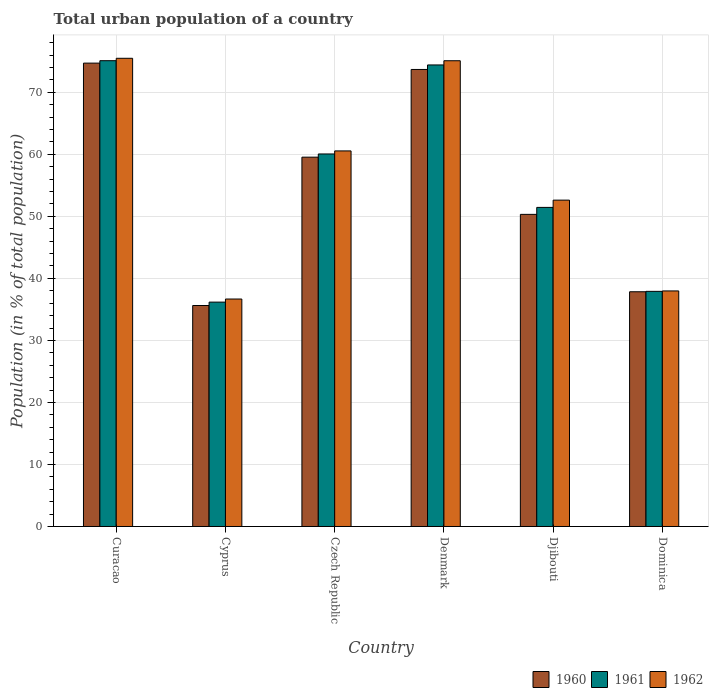Are the number of bars per tick equal to the number of legend labels?
Your answer should be compact. Yes. What is the label of the 3rd group of bars from the left?
Your answer should be very brief. Czech Republic. What is the urban population in 1960 in Dominica?
Your answer should be very brief. 37.85. Across all countries, what is the maximum urban population in 1961?
Ensure brevity in your answer.  75.1. Across all countries, what is the minimum urban population in 1960?
Ensure brevity in your answer.  35.63. In which country was the urban population in 1960 maximum?
Your answer should be compact. Curacao. In which country was the urban population in 1961 minimum?
Give a very brief answer. Cyprus. What is the total urban population in 1961 in the graph?
Provide a short and direct response. 335.12. What is the difference between the urban population in 1962 in Curacao and that in Djibouti?
Ensure brevity in your answer.  22.87. What is the difference between the urban population in 1960 in Dominica and the urban population in 1962 in Djibouti?
Provide a succinct answer. -14.77. What is the average urban population in 1961 per country?
Provide a short and direct response. 55.85. What is the difference between the urban population of/in 1962 and urban population of/in 1960 in Denmark?
Offer a very short reply. 1.41. In how many countries, is the urban population in 1961 greater than 18 %?
Ensure brevity in your answer.  6. What is the ratio of the urban population in 1962 in Czech Republic to that in Dominica?
Offer a very short reply. 1.59. Is the difference between the urban population in 1962 in Cyprus and Djibouti greater than the difference between the urban population in 1960 in Cyprus and Djibouti?
Provide a succinct answer. No. What is the difference between the highest and the second highest urban population in 1962?
Make the answer very short. -0.4. What is the difference between the highest and the lowest urban population in 1961?
Give a very brief answer. 38.93. Is the sum of the urban population in 1962 in Curacao and Dominica greater than the maximum urban population in 1960 across all countries?
Give a very brief answer. Yes. What does the 2nd bar from the left in Curacao represents?
Keep it short and to the point. 1961. What does the 3rd bar from the right in Dominica represents?
Offer a very short reply. 1960. Is it the case that in every country, the sum of the urban population in 1961 and urban population in 1960 is greater than the urban population in 1962?
Provide a short and direct response. Yes. What is the difference between two consecutive major ticks on the Y-axis?
Ensure brevity in your answer.  10. Are the values on the major ticks of Y-axis written in scientific E-notation?
Ensure brevity in your answer.  No. Does the graph contain any zero values?
Offer a terse response. No. Where does the legend appear in the graph?
Your answer should be compact. Bottom right. How many legend labels are there?
Provide a succinct answer. 3. What is the title of the graph?
Your response must be concise. Total urban population of a country. What is the label or title of the X-axis?
Your answer should be compact. Country. What is the label or title of the Y-axis?
Provide a succinct answer. Population (in % of total population). What is the Population (in % of total population) in 1960 in Curacao?
Your answer should be compact. 74.71. What is the Population (in % of total population) in 1961 in Curacao?
Give a very brief answer. 75.1. What is the Population (in % of total population) in 1962 in Curacao?
Provide a succinct answer. 75.49. What is the Population (in % of total population) in 1960 in Cyprus?
Provide a short and direct response. 35.63. What is the Population (in % of total population) of 1961 in Cyprus?
Offer a very short reply. 36.17. What is the Population (in % of total population) in 1962 in Cyprus?
Offer a terse response. 36.67. What is the Population (in % of total population) of 1960 in Czech Republic?
Provide a short and direct response. 59.55. What is the Population (in % of total population) in 1961 in Czech Republic?
Your answer should be very brief. 60.06. What is the Population (in % of total population) in 1962 in Czech Republic?
Give a very brief answer. 60.55. What is the Population (in % of total population) in 1960 in Denmark?
Provide a short and direct response. 73.69. What is the Population (in % of total population) in 1961 in Denmark?
Provide a succinct answer. 74.42. What is the Population (in % of total population) in 1962 in Denmark?
Your answer should be very brief. 75.09. What is the Population (in % of total population) in 1960 in Djibouti?
Give a very brief answer. 50.33. What is the Population (in % of total population) of 1961 in Djibouti?
Provide a short and direct response. 51.45. What is the Population (in % of total population) in 1962 in Djibouti?
Provide a short and direct response. 52.62. What is the Population (in % of total population) in 1960 in Dominica?
Ensure brevity in your answer.  37.85. What is the Population (in % of total population) in 1961 in Dominica?
Your answer should be compact. 37.91. What is the Population (in % of total population) of 1962 in Dominica?
Your answer should be compact. 37.98. Across all countries, what is the maximum Population (in % of total population) in 1960?
Offer a very short reply. 74.71. Across all countries, what is the maximum Population (in % of total population) in 1961?
Your answer should be compact. 75.1. Across all countries, what is the maximum Population (in % of total population) of 1962?
Ensure brevity in your answer.  75.49. Across all countries, what is the minimum Population (in % of total population) in 1960?
Keep it short and to the point. 35.63. Across all countries, what is the minimum Population (in % of total population) of 1961?
Give a very brief answer. 36.17. Across all countries, what is the minimum Population (in % of total population) of 1962?
Offer a very short reply. 36.67. What is the total Population (in % of total population) of 1960 in the graph?
Offer a very short reply. 331.74. What is the total Population (in % of total population) of 1961 in the graph?
Ensure brevity in your answer.  335.12. What is the total Population (in % of total population) in 1962 in the graph?
Ensure brevity in your answer.  338.41. What is the difference between the Population (in % of total population) in 1960 in Curacao and that in Cyprus?
Your response must be concise. 39.08. What is the difference between the Population (in % of total population) of 1961 in Curacao and that in Cyprus?
Provide a succinct answer. 38.93. What is the difference between the Population (in % of total population) of 1962 in Curacao and that in Cyprus?
Your answer should be compact. 38.82. What is the difference between the Population (in % of total population) in 1960 in Curacao and that in Czech Republic?
Make the answer very short. 15.16. What is the difference between the Population (in % of total population) of 1961 in Curacao and that in Czech Republic?
Ensure brevity in your answer.  15.04. What is the difference between the Population (in % of total population) of 1962 in Curacao and that in Czech Republic?
Provide a succinct answer. 14.94. What is the difference between the Population (in % of total population) in 1961 in Curacao and that in Denmark?
Keep it short and to the point. 0.69. What is the difference between the Population (in % of total population) of 1962 in Curacao and that in Denmark?
Your response must be concise. 0.4. What is the difference between the Population (in % of total population) of 1960 in Curacao and that in Djibouti?
Your answer should be compact. 24.39. What is the difference between the Population (in % of total population) in 1961 in Curacao and that in Djibouti?
Provide a short and direct response. 23.65. What is the difference between the Population (in % of total population) of 1962 in Curacao and that in Djibouti?
Offer a very short reply. 22.87. What is the difference between the Population (in % of total population) in 1960 in Curacao and that in Dominica?
Provide a short and direct response. 36.86. What is the difference between the Population (in % of total population) of 1961 in Curacao and that in Dominica?
Give a very brief answer. 37.19. What is the difference between the Population (in % of total population) in 1962 in Curacao and that in Dominica?
Keep it short and to the point. 37.51. What is the difference between the Population (in % of total population) in 1960 in Cyprus and that in Czech Republic?
Your answer should be compact. -23.92. What is the difference between the Population (in % of total population) in 1961 in Cyprus and that in Czech Republic?
Give a very brief answer. -23.89. What is the difference between the Population (in % of total population) in 1962 in Cyprus and that in Czech Republic?
Your answer should be very brief. -23.88. What is the difference between the Population (in % of total population) of 1960 in Cyprus and that in Denmark?
Your response must be concise. -38.06. What is the difference between the Population (in % of total population) of 1961 in Cyprus and that in Denmark?
Your answer should be compact. -38.24. What is the difference between the Population (in % of total population) in 1962 in Cyprus and that in Denmark?
Make the answer very short. -38.42. What is the difference between the Population (in % of total population) in 1960 in Cyprus and that in Djibouti?
Offer a terse response. -14.7. What is the difference between the Population (in % of total population) in 1961 in Cyprus and that in Djibouti?
Keep it short and to the point. -15.27. What is the difference between the Population (in % of total population) in 1962 in Cyprus and that in Djibouti?
Provide a succinct answer. -15.95. What is the difference between the Population (in % of total population) of 1960 in Cyprus and that in Dominica?
Ensure brevity in your answer.  -2.22. What is the difference between the Population (in % of total population) of 1961 in Cyprus and that in Dominica?
Your response must be concise. -1.74. What is the difference between the Population (in % of total population) of 1962 in Cyprus and that in Dominica?
Your response must be concise. -1.3. What is the difference between the Population (in % of total population) in 1960 in Czech Republic and that in Denmark?
Keep it short and to the point. -14.14. What is the difference between the Population (in % of total population) in 1961 in Czech Republic and that in Denmark?
Keep it short and to the point. -14.35. What is the difference between the Population (in % of total population) of 1962 in Czech Republic and that in Denmark?
Make the answer very short. -14.54. What is the difference between the Population (in % of total population) of 1960 in Czech Republic and that in Djibouti?
Ensure brevity in your answer.  9.22. What is the difference between the Population (in % of total population) of 1961 in Czech Republic and that in Djibouti?
Your response must be concise. 8.62. What is the difference between the Population (in % of total population) of 1962 in Czech Republic and that in Djibouti?
Your response must be concise. 7.94. What is the difference between the Population (in % of total population) of 1960 in Czech Republic and that in Dominica?
Your answer should be very brief. 21.7. What is the difference between the Population (in % of total population) of 1961 in Czech Republic and that in Dominica?
Provide a short and direct response. 22.15. What is the difference between the Population (in % of total population) in 1962 in Czech Republic and that in Dominica?
Offer a terse response. 22.58. What is the difference between the Population (in % of total population) of 1960 in Denmark and that in Djibouti?
Offer a very short reply. 23.36. What is the difference between the Population (in % of total population) of 1961 in Denmark and that in Djibouti?
Your response must be concise. 22.97. What is the difference between the Population (in % of total population) of 1962 in Denmark and that in Djibouti?
Make the answer very short. 22.47. What is the difference between the Population (in % of total population) in 1960 in Denmark and that in Dominica?
Keep it short and to the point. 35.84. What is the difference between the Population (in % of total population) of 1961 in Denmark and that in Dominica?
Ensure brevity in your answer.  36.51. What is the difference between the Population (in % of total population) in 1962 in Denmark and that in Dominica?
Provide a succinct answer. 37.11. What is the difference between the Population (in % of total population) in 1960 in Djibouti and that in Dominica?
Provide a short and direct response. 12.48. What is the difference between the Population (in % of total population) of 1961 in Djibouti and that in Dominica?
Offer a very short reply. 13.54. What is the difference between the Population (in % of total population) of 1962 in Djibouti and that in Dominica?
Provide a succinct answer. 14.64. What is the difference between the Population (in % of total population) of 1960 in Curacao and the Population (in % of total population) of 1961 in Cyprus?
Keep it short and to the point. 38.53. What is the difference between the Population (in % of total population) in 1960 in Curacao and the Population (in % of total population) in 1962 in Cyprus?
Offer a terse response. 38.04. What is the difference between the Population (in % of total population) in 1961 in Curacao and the Population (in % of total population) in 1962 in Cyprus?
Offer a very short reply. 38.43. What is the difference between the Population (in % of total population) of 1960 in Curacao and the Population (in % of total population) of 1961 in Czech Republic?
Ensure brevity in your answer.  14.65. What is the difference between the Population (in % of total population) of 1960 in Curacao and the Population (in % of total population) of 1962 in Czech Republic?
Offer a terse response. 14.15. What is the difference between the Population (in % of total population) in 1961 in Curacao and the Population (in % of total population) in 1962 in Czech Republic?
Your answer should be compact. 14.55. What is the difference between the Population (in % of total population) of 1960 in Curacao and the Population (in % of total population) of 1961 in Denmark?
Give a very brief answer. 0.29. What is the difference between the Population (in % of total population) in 1960 in Curacao and the Population (in % of total population) in 1962 in Denmark?
Keep it short and to the point. -0.38. What is the difference between the Population (in % of total population) in 1961 in Curacao and the Population (in % of total population) in 1962 in Denmark?
Provide a succinct answer. 0.01. What is the difference between the Population (in % of total population) in 1960 in Curacao and the Population (in % of total population) in 1961 in Djibouti?
Give a very brief answer. 23.26. What is the difference between the Population (in % of total population) in 1960 in Curacao and the Population (in % of total population) in 1962 in Djibouti?
Ensure brevity in your answer.  22.09. What is the difference between the Population (in % of total population) in 1961 in Curacao and the Population (in % of total population) in 1962 in Djibouti?
Provide a succinct answer. 22.48. What is the difference between the Population (in % of total population) in 1960 in Curacao and the Population (in % of total population) in 1961 in Dominica?
Your answer should be very brief. 36.8. What is the difference between the Population (in % of total population) in 1960 in Curacao and the Population (in % of total population) in 1962 in Dominica?
Your answer should be compact. 36.73. What is the difference between the Population (in % of total population) in 1961 in Curacao and the Population (in % of total population) in 1962 in Dominica?
Your answer should be compact. 37.12. What is the difference between the Population (in % of total population) in 1960 in Cyprus and the Population (in % of total population) in 1961 in Czech Republic?
Provide a short and direct response. -24.43. What is the difference between the Population (in % of total population) in 1960 in Cyprus and the Population (in % of total population) in 1962 in Czech Republic?
Provide a succinct answer. -24.93. What is the difference between the Population (in % of total population) of 1961 in Cyprus and the Population (in % of total population) of 1962 in Czech Republic?
Give a very brief answer. -24.38. What is the difference between the Population (in % of total population) in 1960 in Cyprus and the Population (in % of total population) in 1961 in Denmark?
Provide a succinct answer. -38.79. What is the difference between the Population (in % of total population) of 1960 in Cyprus and the Population (in % of total population) of 1962 in Denmark?
Give a very brief answer. -39.47. What is the difference between the Population (in % of total population) of 1961 in Cyprus and the Population (in % of total population) of 1962 in Denmark?
Give a very brief answer. -38.92. What is the difference between the Population (in % of total population) of 1960 in Cyprus and the Population (in % of total population) of 1961 in Djibouti?
Offer a very short reply. -15.82. What is the difference between the Population (in % of total population) in 1960 in Cyprus and the Population (in % of total population) in 1962 in Djibouti?
Give a very brief answer. -16.99. What is the difference between the Population (in % of total population) of 1961 in Cyprus and the Population (in % of total population) of 1962 in Djibouti?
Offer a very short reply. -16.44. What is the difference between the Population (in % of total population) in 1960 in Cyprus and the Population (in % of total population) in 1961 in Dominica?
Provide a short and direct response. -2.28. What is the difference between the Population (in % of total population) in 1960 in Cyprus and the Population (in % of total population) in 1962 in Dominica?
Provide a succinct answer. -2.35. What is the difference between the Population (in % of total population) of 1961 in Cyprus and the Population (in % of total population) of 1962 in Dominica?
Provide a succinct answer. -1.8. What is the difference between the Population (in % of total population) of 1960 in Czech Republic and the Population (in % of total population) of 1961 in Denmark?
Give a very brief answer. -14.87. What is the difference between the Population (in % of total population) in 1960 in Czech Republic and the Population (in % of total population) in 1962 in Denmark?
Offer a very short reply. -15.54. What is the difference between the Population (in % of total population) of 1961 in Czech Republic and the Population (in % of total population) of 1962 in Denmark?
Ensure brevity in your answer.  -15.03. What is the difference between the Population (in % of total population) in 1960 in Czech Republic and the Population (in % of total population) in 1961 in Djibouti?
Your answer should be very brief. 8.1. What is the difference between the Population (in % of total population) in 1960 in Czech Republic and the Population (in % of total population) in 1962 in Djibouti?
Provide a short and direct response. 6.93. What is the difference between the Population (in % of total population) of 1961 in Czech Republic and the Population (in % of total population) of 1962 in Djibouti?
Keep it short and to the point. 7.44. What is the difference between the Population (in % of total population) in 1960 in Czech Republic and the Population (in % of total population) in 1961 in Dominica?
Your response must be concise. 21.64. What is the difference between the Population (in % of total population) in 1960 in Czech Republic and the Population (in % of total population) in 1962 in Dominica?
Offer a very short reply. 21.57. What is the difference between the Population (in % of total population) in 1961 in Czech Republic and the Population (in % of total population) in 1962 in Dominica?
Give a very brief answer. 22.08. What is the difference between the Population (in % of total population) in 1960 in Denmark and the Population (in % of total population) in 1961 in Djibouti?
Give a very brief answer. 22.24. What is the difference between the Population (in % of total population) in 1960 in Denmark and the Population (in % of total population) in 1962 in Djibouti?
Your answer should be very brief. 21.07. What is the difference between the Population (in % of total population) in 1961 in Denmark and the Population (in % of total population) in 1962 in Djibouti?
Your response must be concise. 21.8. What is the difference between the Population (in % of total population) in 1960 in Denmark and the Population (in % of total population) in 1961 in Dominica?
Keep it short and to the point. 35.77. What is the difference between the Population (in % of total population) of 1960 in Denmark and the Population (in % of total population) of 1962 in Dominica?
Your answer should be compact. 35.71. What is the difference between the Population (in % of total population) in 1961 in Denmark and the Population (in % of total population) in 1962 in Dominica?
Your answer should be compact. 36.44. What is the difference between the Population (in % of total population) of 1960 in Djibouti and the Population (in % of total population) of 1961 in Dominica?
Keep it short and to the point. 12.41. What is the difference between the Population (in % of total population) of 1960 in Djibouti and the Population (in % of total population) of 1962 in Dominica?
Provide a succinct answer. 12.35. What is the difference between the Population (in % of total population) in 1961 in Djibouti and the Population (in % of total population) in 1962 in Dominica?
Ensure brevity in your answer.  13.47. What is the average Population (in % of total population) of 1960 per country?
Give a very brief answer. 55.29. What is the average Population (in % of total population) of 1961 per country?
Give a very brief answer. 55.85. What is the average Population (in % of total population) in 1962 per country?
Your answer should be very brief. 56.4. What is the difference between the Population (in % of total population) in 1960 and Population (in % of total population) in 1961 in Curacao?
Keep it short and to the point. -0.39. What is the difference between the Population (in % of total population) in 1960 and Population (in % of total population) in 1962 in Curacao?
Offer a very short reply. -0.78. What is the difference between the Population (in % of total population) in 1961 and Population (in % of total population) in 1962 in Curacao?
Offer a very short reply. -0.39. What is the difference between the Population (in % of total population) in 1960 and Population (in % of total population) in 1961 in Cyprus?
Your answer should be compact. -0.55. What is the difference between the Population (in % of total population) in 1960 and Population (in % of total population) in 1962 in Cyprus?
Make the answer very short. -1.05. What is the difference between the Population (in % of total population) in 1961 and Population (in % of total population) in 1962 in Cyprus?
Provide a succinct answer. -0.5. What is the difference between the Population (in % of total population) in 1960 and Population (in % of total population) in 1961 in Czech Republic?
Offer a terse response. -0.52. What is the difference between the Population (in % of total population) of 1960 and Population (in % of total population) of 1962 in Czech Republic?
Offer a terse response. -1.01. What is the difference between the Population (in % of total population) of 1961 and Population (in % of total population) of 1962 in Czech Republic?
Keep it short and to the point. -0.49. What is the difference between the Population (in % of total population) of 1960 and Population (in % of total population) of 1961 in Denmark?
Give a very brief answer. -0.73. What is the difference between the Population (in % of total population) of 1960 and Population (in % of total population) of 1962 in Denmark?
Offer a terse response. -1.41. What is the difference between the Population (in % of total population) in 1961 and Population (in % of total population) in 1962 in Denmark?
Keep it short and to the point. -0.68. What is the difference between the Population (in % of total population) of 1960 and Population (in % of total population) of 1961 in Djibouti?
Offer a very short reply. -1.12. What is the difference between the Population (in % of total population) of 1960 and Population (in % of total population) of 1962 in Djibouti?
Provide a short and direct response. -2.29. What is the difference between the Population (in % of total population) of 1961 and Population (in % of total population) of 1962 in Djibouti?
Provide a succinct answer. -1.17. What is the difference between the Population (in % of total population) of 1960 and Population (in % of total population) of 1961 in Dominica?
Ensure brevity in your answer.  -0.07. What is the difference between the Population (in % of total population) of 1960 and Population (in % of total population) of 1962 in Dominica?
Provide a succinct answer. -0.13. What is the difference between the Population (in % of total population) in 1961 and Population (in % of total population) in 1962 in Dominica?
Your answer should be very brief. -0.07. What is the ratio of the Population (in % of total population) of 1960 in Curacao to that in Cyprus?
Your answer should be compact. 2.1. What is the ratio of the Population (in % of total population) in 1961 in Curacao to that in Cyprus?
Offer a very short reply. 2.08. What is the ratio of the Population (in % of total population) of 1962 in Curacao to that in Cyprus?
Give a very brief answer. 2.06. What is the ratio of the Population (in % of total population) of 1960 in Curacao to that in Czech Republic?
Provide a short and direct response. 1.25. What is the ratio of the Population (in % of total population) in 1961 in Curacao to that in Czech Republic?
Your answer should be compact. 1.25. What is the ratio of the Population (in % of total population) of 1962 in Curacao to that in Czech Republic?
Make the answer very short. 1.25. What is the ratio of the Population (in % of total population) of 1960 in Curacao to that in Denmark?
Ensure brevity in your answer.  1.01. What is the ratio of the Population (in % of total population) in 1961 in Curacao to that in Denmark?
Provide a succinct answer. 1.01. What is the ratio of the Population (in % of total population) in 1962 in Curacao to that in Denmark?
Make the answer very short. 1.01. What is the ratio of the Population (in % of total population) in 1960 in Curacao to that in Djibouti?
Your answer should be very brief. 1.48. What is the ratio of the Population (in % of total population) of 1961 in Curacao to that in Djibouti?
Provide a succinct answer. 1.46. What is the ratio of the Population (in % of total population) of 1962 in Curacao to that in Djibouti?
Provide a short and direct response. 1.43. What is the ratio of the Population (in % of total population) of 1960 in Curacao to that in Dominica?
Your answer should be very brief. 1.97. What is the ratio of the Population (in % of total population) in 1961 in Curacao to that in Dominica?
Your response must be concise. 1.98. What is the ratio of the Population (in % of total population) of 1962 in Curacao to that in Dominica?
Offer a very short reply. 1.99. What is the ratio of the Population (in % of total population) in 1960 in Cyprus to that in Czech Republic?
Provide a short and direct response. 0.6. What is the ratio of the Population (in % of total population) of 1961 in Cyprus to that in Czech Republic?
Make the answer very short. 0.6. What is the ratio of the Population (in % of total population) of 1962 in Cyprus to that in Czech Republic?
Ensure brevity in your answer.  0.61. What is the ratio of the Population (in % of total population) in 1960 in Cyprus to that in Denmark?
Your answer should be very brief. 0.48. What is the ratio of the Population (in % of total population) in 1961 in Cyprus to that in Denmark?
Your answer should be compact. 0.49. What is the ratio of the Population (in % of total population) in 1962 in Cyprus to that in Denmark?
Your response must be concise. 0.49. What is the ratio of the Population (in % of total population) in 1960 in Cyprus to that in Djibouti?
Offer a very short reply. 0.71. What is the ratio of the Population (in % of total population) in 1961 in Cyprus to that in Djibouti?
Provide a short and direct response. 0.7. What is the ratio of the Population (in % of total population) in 1962 in Cyprus to that in Djibouti?
Provide a succinct answer. 0.7. What is the ratio of the Population (in % of total population) of 1960 in Cyprus to that in Dominica?
Offer a very short reply. 0.94. What is the ratio of the Population (in % of total population) in 1961 in Cyprus to that in Dominica?
Offer a very short reply. 0.95. What is the ratio of the Population (in % of total population) of 1962 in Cyprus to that in Dominica?
Your answer should be compact. 0.97. What is the ratio of the Population (in % of total population) of 1960 in Czech Republic to that in Denmark?
Offer a terse response. 0.81. What is the ratio of the Population (in % of total population) in 1961 in Czech Republic to that in Denmark?
Provide a succinct answer. 0.81. What is the ratio of the Population (in % of total population) in 1962 in Czech Republic to that in Denmark?
Your answer should be very brief. 0.81. What is the ratio of the Population (in % of total population) of 1960 in Czech Republic to that in Djibouti?
Your response must be concise. 1.18. What is the ratio of the Population (in % of total population) in 1961 in Czech Republic to that in Djibouti?
Provide a short and direct response. 1.17. What is the ratio of the Population (in % of total population) of 1962 in Czech Republic to that in Djibouti?
Your answer should be compact. 1.15. What is the ratio of the Population (in % of total population) of 1960 in Czech Republic to that in Dominica?
Give a very brief answer. 1.57. What is the ratio of the Population (in % of total population) of 1961 in Czech Republic to that in Dominica?
Provide a short and direct response. 1.58. What is the ratio of the Population (in % of total population) of 1962 in Czech Republic to that in Dominica?
Your answer should be compact. 1.59. What is the ratio of the Population (in % of total population) of 1960 in Denmark to that in Djibouti?
Your answer should be compact. 1.46. What is the ratio of the Population (in % of total population) in 1961 in Denmark to that in Djibouti?
Your answer should be compact. 1.45. What is the ratio of the Population (in % of total population) in 1962 in Denmark to that in Djibouti?
Your answer should be compact. 1.43. What is the ratio of the Population (in % of total population) in 1960 in Denmark to that in Dominica?
Ensure brevity in your answer.  1.95. What is the ratio of the Population (in % of total population) of 1961 in Denmark to that in Dominica?
Offer a very short reply. 1.96. What is the ratio of the Population (in % of total population) of 1962 in Denmark to that in Dominica?
Provide a short and direct response. 1.98. What is the ratio of the Population (in % of total population) of 1960 in Djibouti to that in Dominica?
Offer a very short reply. 1.33. What is the ratio of the Population (in % of total population) of 1961 in Djibouti to that in Dominica?
Your response must be concise. 1.36. What is the ratio of the Population (in % of total population) of 1962 in Djibouti to that in Dominica?
Your answer should be compact. 1.39. What is the difference between the highest and the second highest Population (in % of total population) in 1961?
Your answer should be very brief. 0.69. What is the difference between the highest and the second highest Population (in % of total population) in 1962?
Offer a very short reply. 0.4. What is the difference between the highest and the lowest Population (in % of total population) in 1960?
Offer a terse response. 39.08. What is the difference between the highest and the lowest Population (in % of total population) of 1961?
Offer a terse response. 38.93. What is the difference between the highest and the lowest Population (in % of total population) in 1962?
Your answer should be compact. 38.82. 